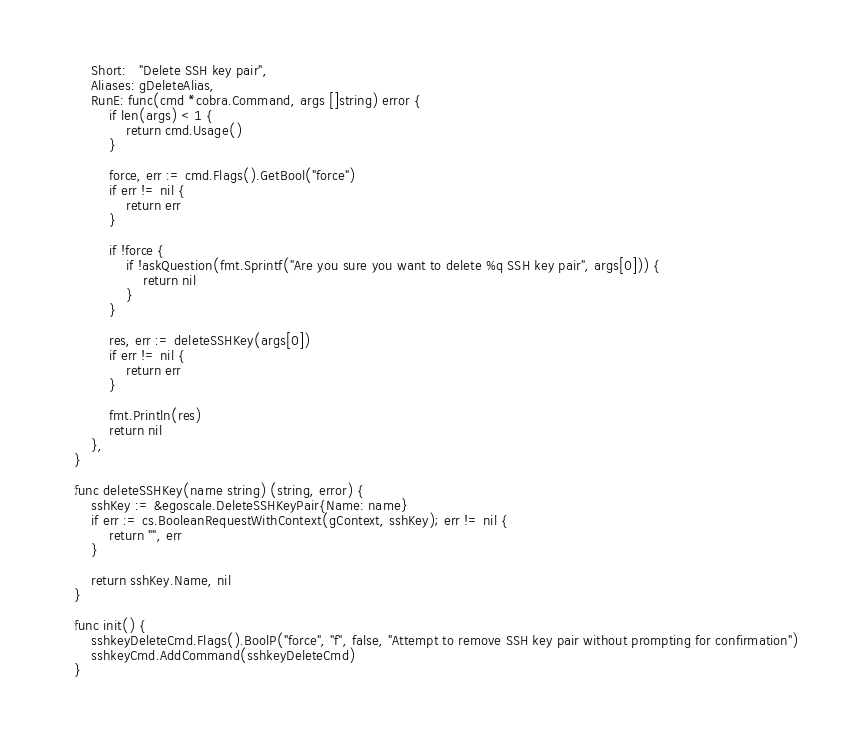Convert code to text. <code><loc_0><loc_0><loc_500><loc_500><_Go_>	Short:   "Delete SSH key pair",
	Aliases: gDeleteAlias,
	RunE: func(cmd *cobra.Command, args []string) error {
		if len(args) < 1 {
			return cmd.Usage()
		}

		force, err := cmd.Flags().GetBool("force")
		if err != nil {
			return err
		}

		if !force {
			if !askQuestion(fmt.Sprintf("Are you sure you want to delete %q SSH key pair", args[0])) {
				return nil
			}
		}

		res, err := deleteSSHKey(args[0])
		if err != nil {
			return err
		}

		fmt.Println(res)
		return nil
	},
}

func deleteSSHKey(name string) (string, error) {
	sshKey := &egoscale.DeleteSSHKeyPair{Name: name}
	if err := cs.BooleanRequestWithContext(gContext, sshKey); err != nil {
		return "", err
	}

	return sshKey.Name, nil
}

func init() {
	sshkeyDeleteCmd.Flags().BoolP("force", "f", false, "Attempt to remove SSH key pair without prompting for confirmation")
	sshkeyCmd.AddCommand(sshkeyDeleteCmd)
}
</code> 